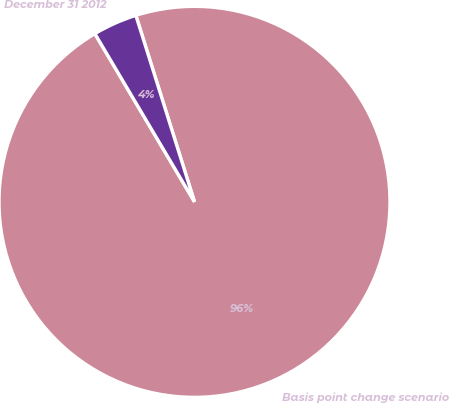Convert chart. <chart><loc_0><loc_0><loc_500><loc_500><pie_chart><fcel>Basis point change scenario<fcel>December 31 2012<nl><fcel>96.34%<fcel>3.66%<nl></chart> 